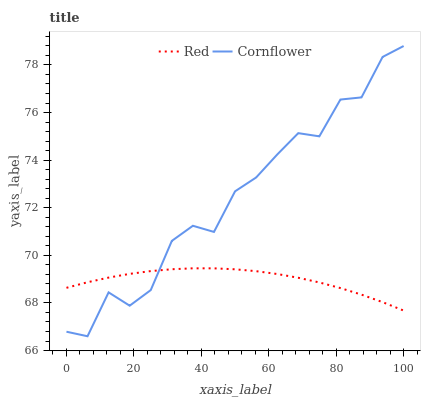Does Red have the minimum area under the curve?
Answer yes or no. Yes. Does Cornflower have the maximum area under the curve?
Answer yes or no. Yes. Does Red have the maximum area under the curve?
Answer yes or no. No. Is Red the smoothest?
Answer yes or no. Yes. Is Cornflower the roughest?
Answer yes or no. Yes. Is Red the roughest?
Answer yes or no. No. Does Red have the lowest value?
Answer yes or no. No. Does Red have the highest value?
Answer yes or no. No. 